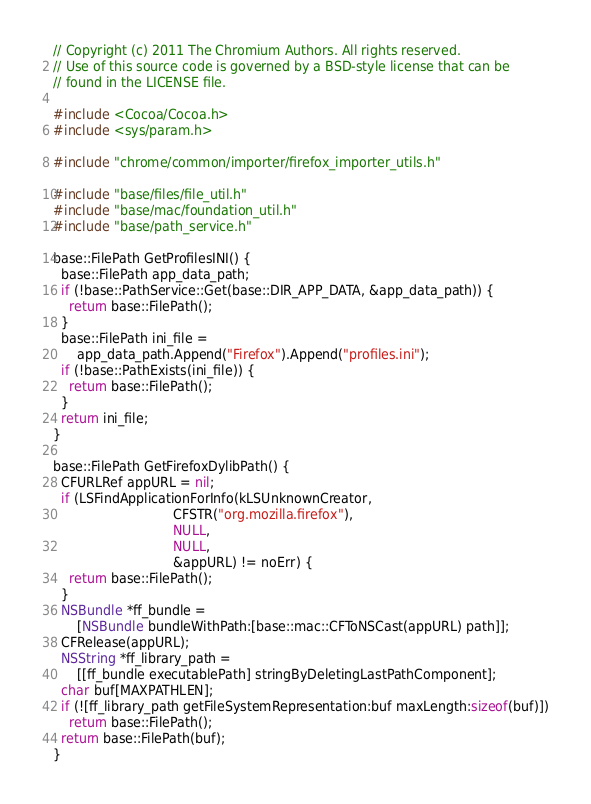Convert code to text. <code><loc_0><loc_0><loc_500><loc_500><_ObjectiveC_>// Copyright (c) 2011 The Chromium Authors. All rights reserved.
// Use of this source code is governed by a BSD-style license that can be
// found in the LICENSE file.

#include <Cocoa/Cocoa.h>
#include <sys/param.h>

#include "chrome/common/importer/firefox_importer_utils.h"

#include "base/files/file_util.h"
#include "base/mac/foundation_util.h"
#include "base/path_service.h"

base::FilePath GetProfilesINI() {
  base::FilePath app_data_path;
  if (!base::PathService::Get(base::DIR_APP_DATA, &app_data_path)) {
    return base::FilePath();
  }
  base::FilePath ini_file =
      app_data_path.Append("Firefox").Append("profiles.ini");
  if (!base::PathExists(ini_file)) {
    return base::FilePath();
  }
  return ini_file;
}

base::FilePath GetFirefoxDylibPath() {
  CFURLRef appURL = nil;
  if (LSFindApplicationForInfo(kLSUnknownCreator,
                              CFSTR("org.mozilla.firefox"),
                              NULL,
                              NULL,
                              &appURL) != noErr) {
    return base::FilePath();
  }
  NSBundle *ff_bundle =
      [NSBundle bundleWithPath:[base::mac::CFToNSCast(appURL) path]];
  CFRelease(appURL);
  NSString *ff_library_path =
      [[ff_bundle executablePath] stringByDeletingLastPathComponent];
  char buf[MAXPATHLEN];
  if (![ff_library_path getFileSystemRepresentation:buf maxLength:sizeof(buf)])
    return base::FilePath();
  return base::FilePath(buf);
}
</code> 